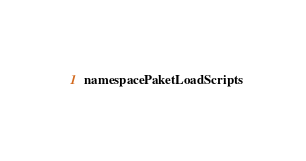<code> <loc_0><loc_0><loc_500><loc_500><_C#_>namespace PaketLoadScripts
</code> 